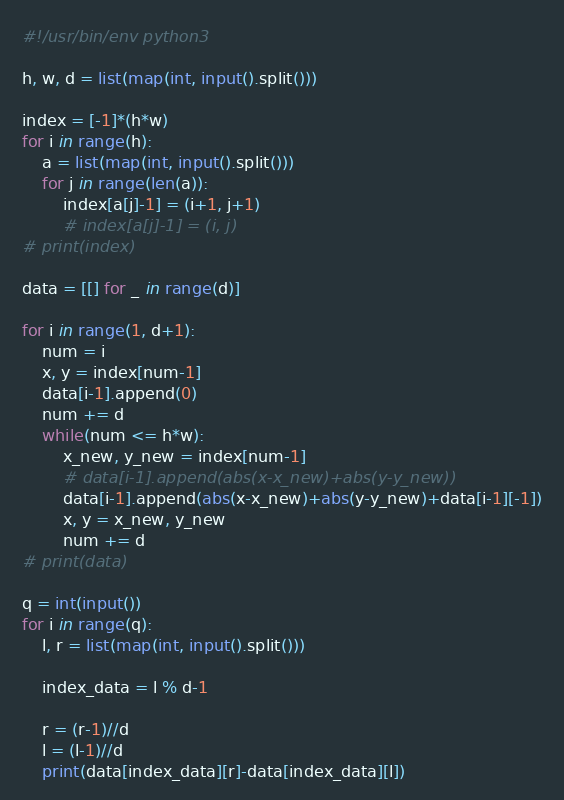Convert code to text. <code><loc_0><loc_0><loc_500><loc_500><_Python_>#!/usr/bin/env python3

h, w, d = list(map(int, input().split()))

index = [-1]*(h*w)
for i in range(h):
    a = list(map(int, input().split()))
    for j in range(len(a)):
        index[a[j]-1] = (i+1, j+1)
        # index[a[j]-1] = (i, j)
# print(index)

data = [[] for _ in range(d)]

for i in range(1, d+1):
    num = i
    x, y = index[num-1]
    data[i-1].append(0)
    num += d
    while(num <= h*w):
        x_new, y_new = index[num-1]
        # data[i-1].append(abs(x-x_new)+abs(y-y_new))
        data[i-1].append(abs(x-x_new)+abs(y-y_new)+data[i-1][-1])
        x, y = x_new, y_new
        num += d
# print(data)

q = int(input())
for i in range(q):
    l, r = list(map(int, input().split()))

    index_data = l % d-1

    r = (r-1)//d
    l = (l-1)//d
    print(data[index_data][r]-data[index_data][l])
</code> 